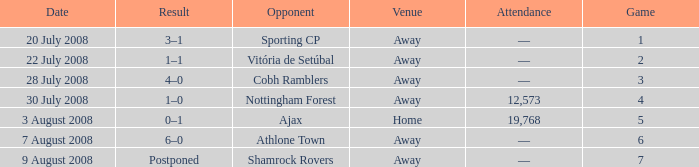What is the result of the game with a game number greater than 6 and an away venue? Postponed. 